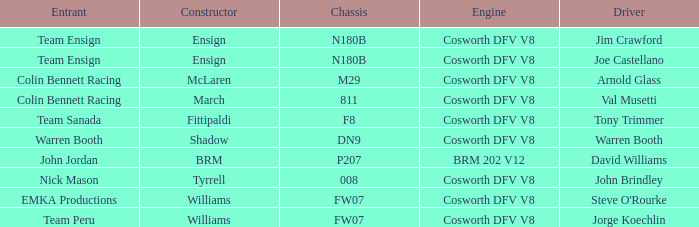What team uses a Cosworth DFV V8 engine and DN9 Chassis? Warren Booth. Give me the full table as a dictionary. {'header': ['Entrant', 'Constructor', 'Chassis', 'Engine', 'Driver'], 'rows': [['Team Ensign', 'Ensign', 'N180B', 'Cosworth DFV V8', 'Jim Crawford'], ['Team Ensign', 'Ensign', 'N180B', 'Cosworth DFV V8', 'Joe Castellano'], ['Colin Bennett Racing', 'McLaren', 'M29', 'Cosworth DFV V8', 'Arnold Glass'], ['Colin Bennett Racing', 'March', '811', 'Cosworth DFV V8', 'Val Musetti'], ['Team Sanada', 'Fittipaldi', 'F8', 'Cosworth DFV V8', 'Tony Trimmer'], ['Warren Booth', 'Shadow', 'DN9', 'Cosworth DFV V8', 'Warren Booth'], ['John Jordan', 'BRM', 'P207', 'BRM 202 V12', 'David Williams'], ['Nick Mason', 'Tyrrell', '008', 'Cosworth DFV V8', 'John Brindley'], ['EMKA Productions', 'Williams', 'FW07', 'Cosworth DFV V8', "Steve O'Rourke"], ['Team Peru', 'Williams', 'FW07', 'Cosworth DFV V8', 'Jorge Koechlin']]} 